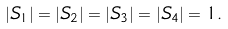<formula> <loc_0><loc_0><loc_500><loc_500>| S _ { 1 } | = | S _ { 2 } | = | S _ { 3 } | = | S _ { 4 } | = 1 .</formula> 